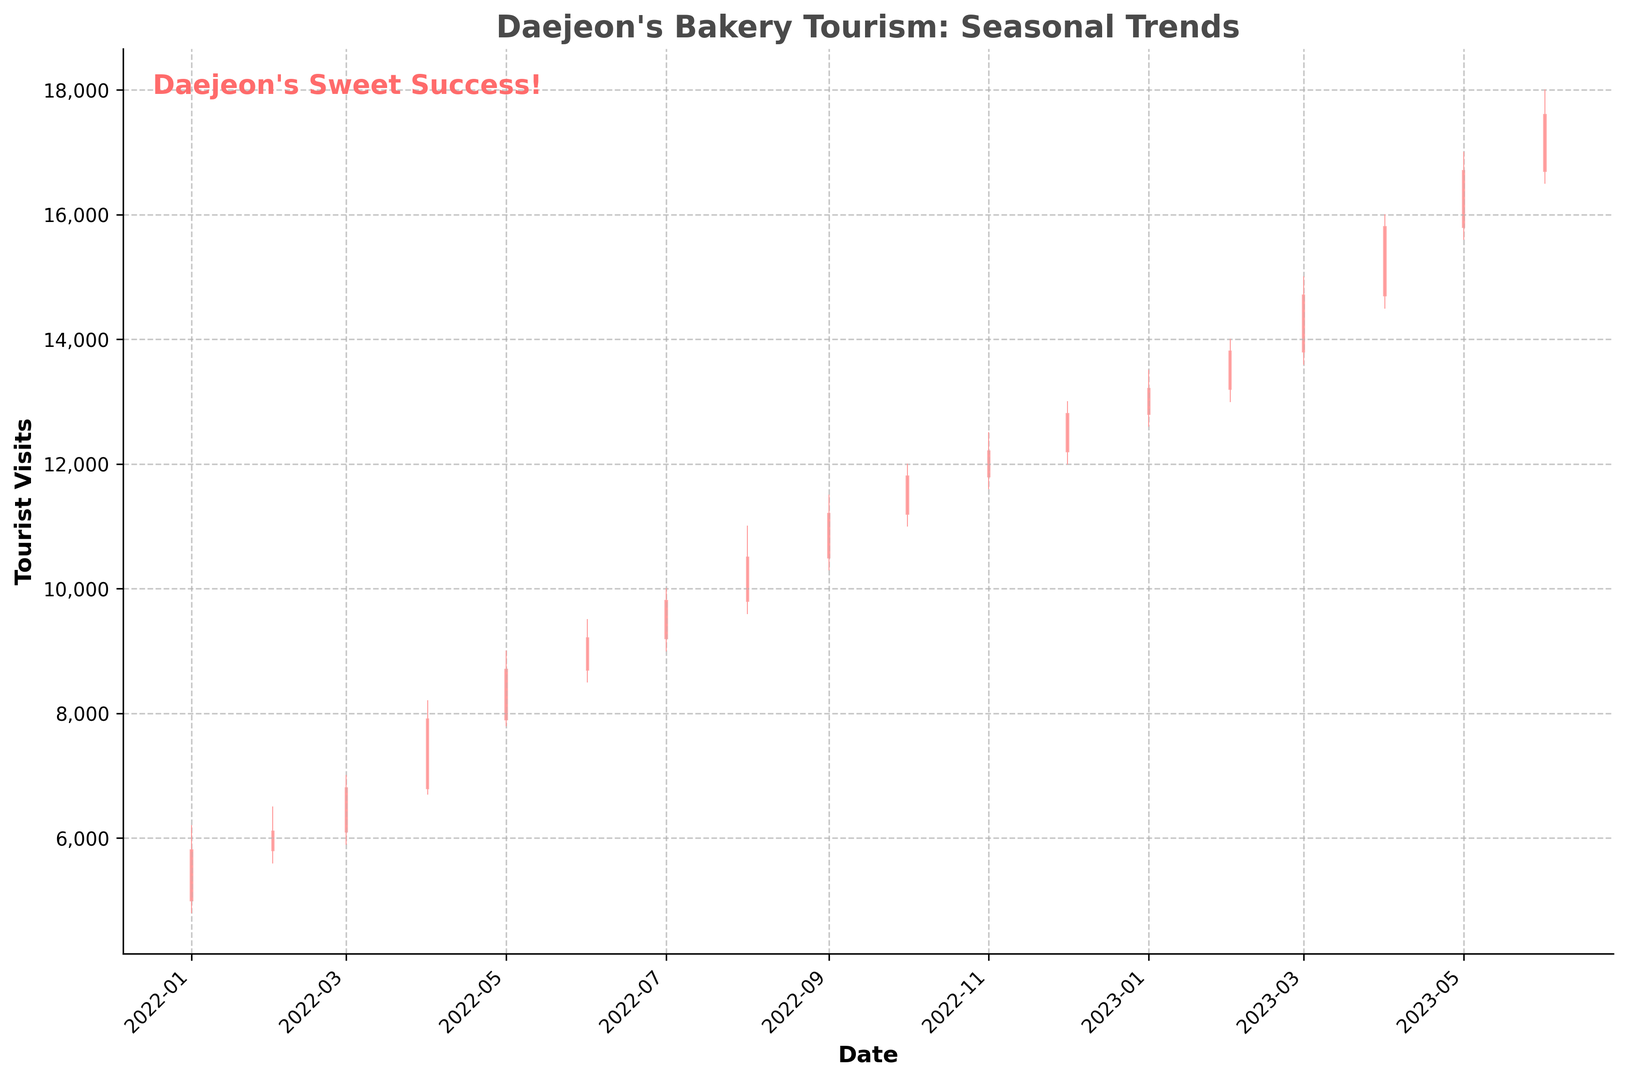Which month had the highest tourist visits to Daejeon's bakery attractions? First, look at which candlestick has the highest "High" value. Here, the "High" value reaches 18,000 in June 2023, which is the highest point on the plot.
Answer: June 2023 What is the difference between tourist visits in August 2022 compared to August 2023? For August 2022, the "Close" value is 10,500, and for August 2023, the data is not available on the chart. Therefore, the comparison is not possible with the given data.
Answer: Not applicable How many more tourist visits were there in April 2023 compared to April 2022? April 2022 had a "Close" value of 7,900, and April 2023 had a "Close" value of 15,800. Subtract the two values: 15,800 - 7,900 = 7,900.
Answer: 7,900 Which month showed the largest increase in tourist visits compared to the previous month? To find the largest month-to-month increase, calculate the difference in "Close" values between consecutive months. The largest difference is from March 2023 (14,700) to April 2023 (15,800), which is 1,100.
Answer: April 2023 Was there a seasonal decline in tourist visits, and if so, in which months did it occur? Look for months where the "Close" value is lower than the previous month. A decline is visible from August 2022 (10,500) to September 2022 (11,200) to October 2022 (11,800), breaking the trend with small declines.
Answer: None detected Is there a discernible trend in tourist visits to Daejeon's bakery attractions over time? The trend can be viewed by observing the overall direction of the candlesticks. Starting from January 2022 to June 2023, the "Close" values consistently increase, indicating a growing trend in bakery tourism.
Answer: Upward trend How do tourist visits in January 2023 compare to those in January 2022? The "Close" value for January 2022 is 5,800, and for January 2023, it is 13,200. Comparing both values shows that January 2023 had higher tourist visits.
Answer: Higher in January 2023 What was the opening value for tourist visits in February 2023, and how did it change by the end of the month? The "Open" value for February 2023 is 13,200, and the "Close" value is 13,800. Hence, it increased by 600.
Answer: Increased by 600 What are the average monthly tourist visits in 2022? Add the "Close" values for each month in 2022 and divide by 12. (5800+6100+6800+7900+8700+9200+9800+10500+11200+11800+12200+12800) / 12 = 9383.3.
Answer: 9,383 Overall, did Daejeon experience more popular bakery tourism during the summer or winter months? Aggregate tourist visits by summing the "Close" values for summer (Jun, Jul, Aug) and winter (Dec, Jan, Feb) months. Summer 2022 has values (9,200 + 9,800 + 10,500) = 29,500 while Winter 2022/2023 has values (12,800 + 13,200 + 13,800) = 39,800. Winter months had higher visits.
Answer: Winter months 